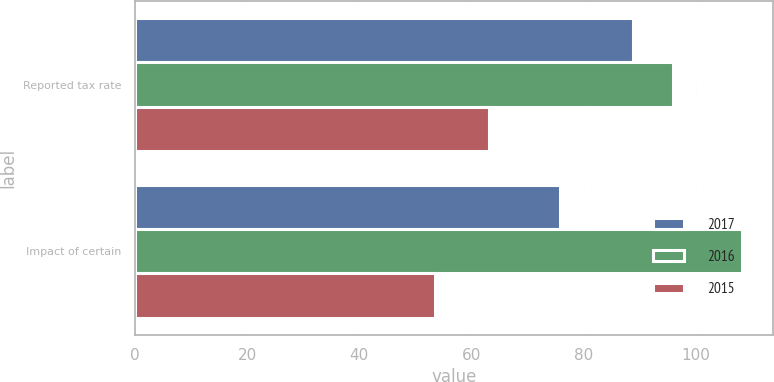Convert chart to OTSL. <chart><loc_0><loc_0><loc_500><loc_500><stacked_bar_chart><ecel><fcel>Reported tax rate<fcel>Impact of certain<nl><fcel>2017<fcel>88.8<fcel>75.8<nl><fcel>2016<fcel>95.9<fcel>108.3<nl><fcel>2015<fcel>63.2<fcel>53.5<nl></chart> 